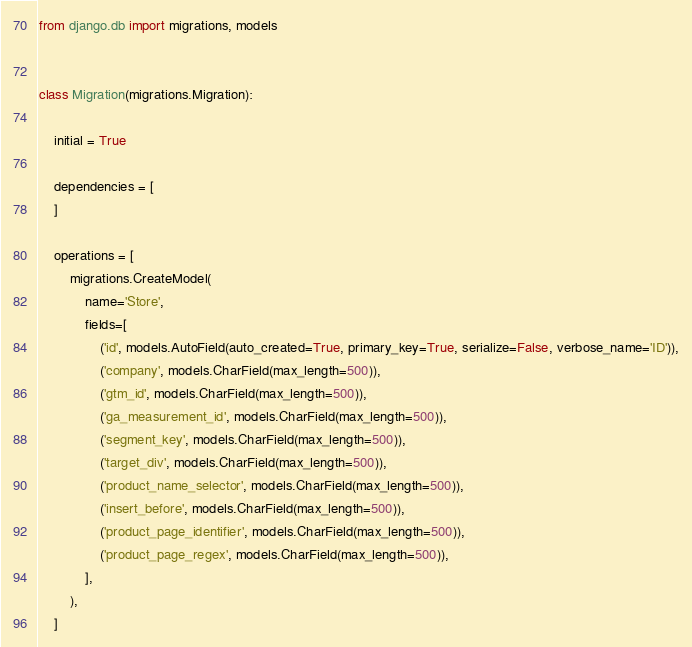Convert code to text. <code><loc_0><loc_0><loc_500><loc_500><_Python_>
from django.db import migrations, models


class Migration(migrations.Migration):

    initial = True

    dependencies = [
    ]

    operations = [
        migrations.CreateModel(
            name='Store',
            fields=[
                ('id', models.AutoField(auto_created=True, primary_key=True, serialize=False, verbose_name='ID')),
                ('company', models.CharField(max_length=500)),
                ('gtm_id', models.CharField(max_length=500)),
                ('ga_measurement_id', models.CharField(max_length=500)),
                ('segment_key', models.CharField(max_length=500)),
                ('target_div', models.CharField(max_length=500)),
                ('product_name_selector', models.CharField(max_length=500)),
                ('insert_before', models.CharField(max_length=500)),
                ('product_page_identifier', models.CharField(max_length=500)),
                ('product_page_regex', models.CharField(max_length=500)),
            ],
        ),
    ]
</code> 